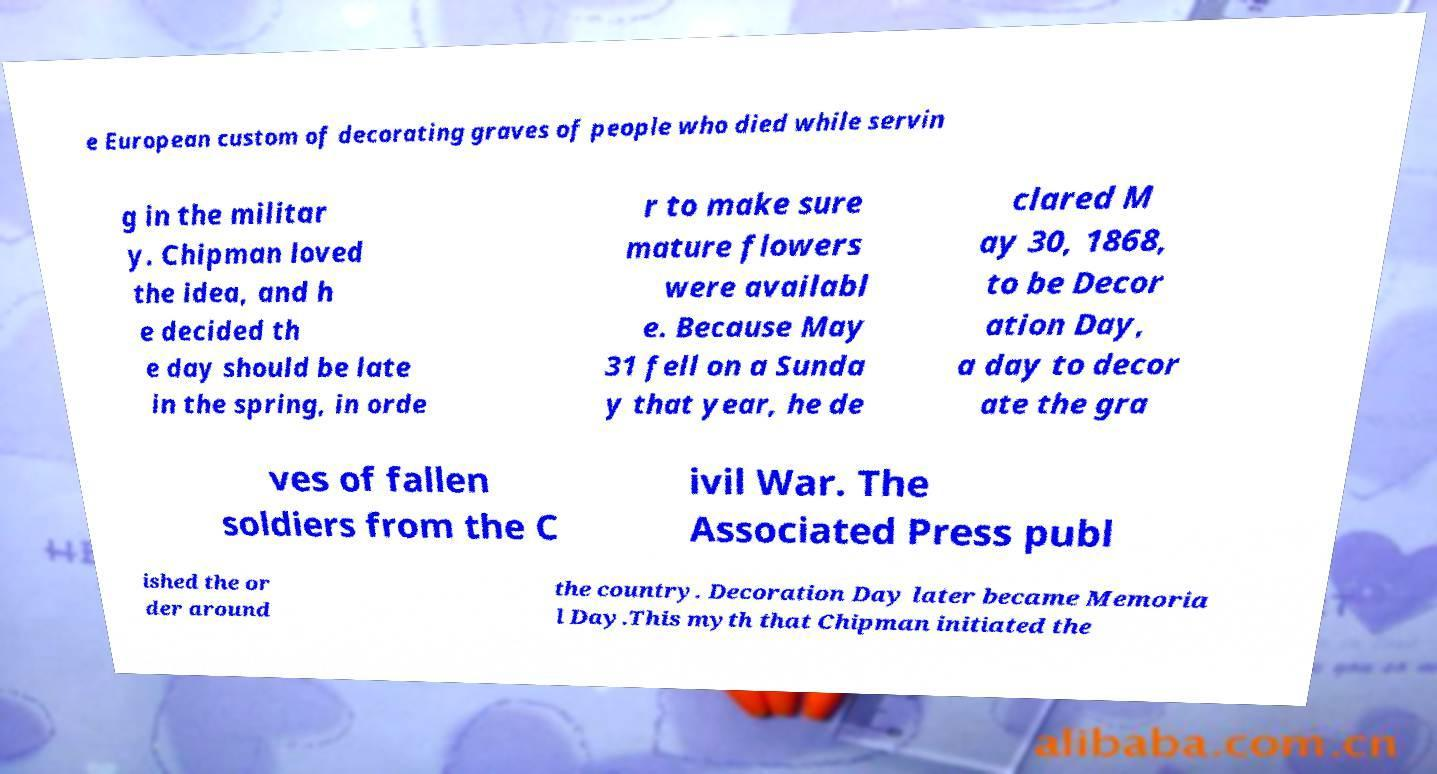Please read and relay the text visible in this image. What does it say? e European custom of decorating graves of people who died while servin g in the militar y. Chipman loved the idea, and h e decided th e day should be late in the spring, in orde r to make sure mature flowers were availabl e. Because May 31 fell on a Sunda y that year, he de clared M ay 30, 1868, to be Decor ation Day, a day to decor ate the gra ves of fallen soldiers from the C ivil War. The Associated Press publ ished the or der around the country. Decoration Day later became Memoria l Day.This myth that Chipman initiated the 